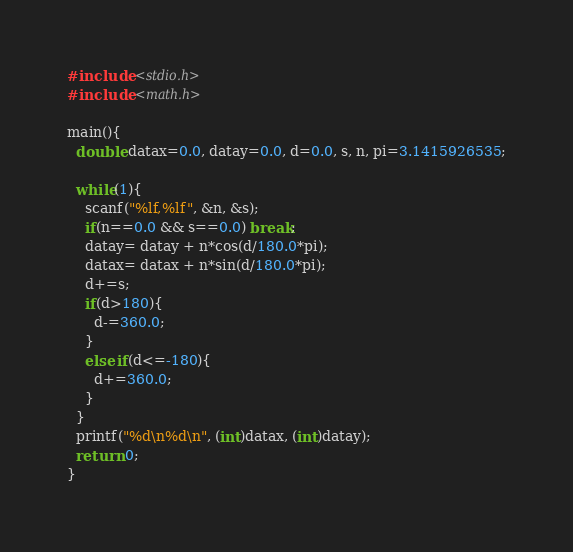Convert code to text. <code><loc_0><loc_0><loc_500><loc_500><_C_>#include <stdio.h>
#include <math.h>

main(){
  double datax=0.0, datay=0.0, d=0.0, s, n, pi=3.1415926535;

  while(1){
    scanf("%lf,%lf", &n, &s);
    if(n==0.0 && s==0.0) break;
    datay= datay + n*cos(d/180.0*pi);
    datax= datax + n*sin(d/180.0*pi);
    d+=s;
    if(d>180){
      d-=360.0;
    }
    else if(d<=-180){
      d+=360.0;	
    }
  }
  printf("%d\n%d\n", (int)datax, (int)datay);
  return 0;
}</code> 